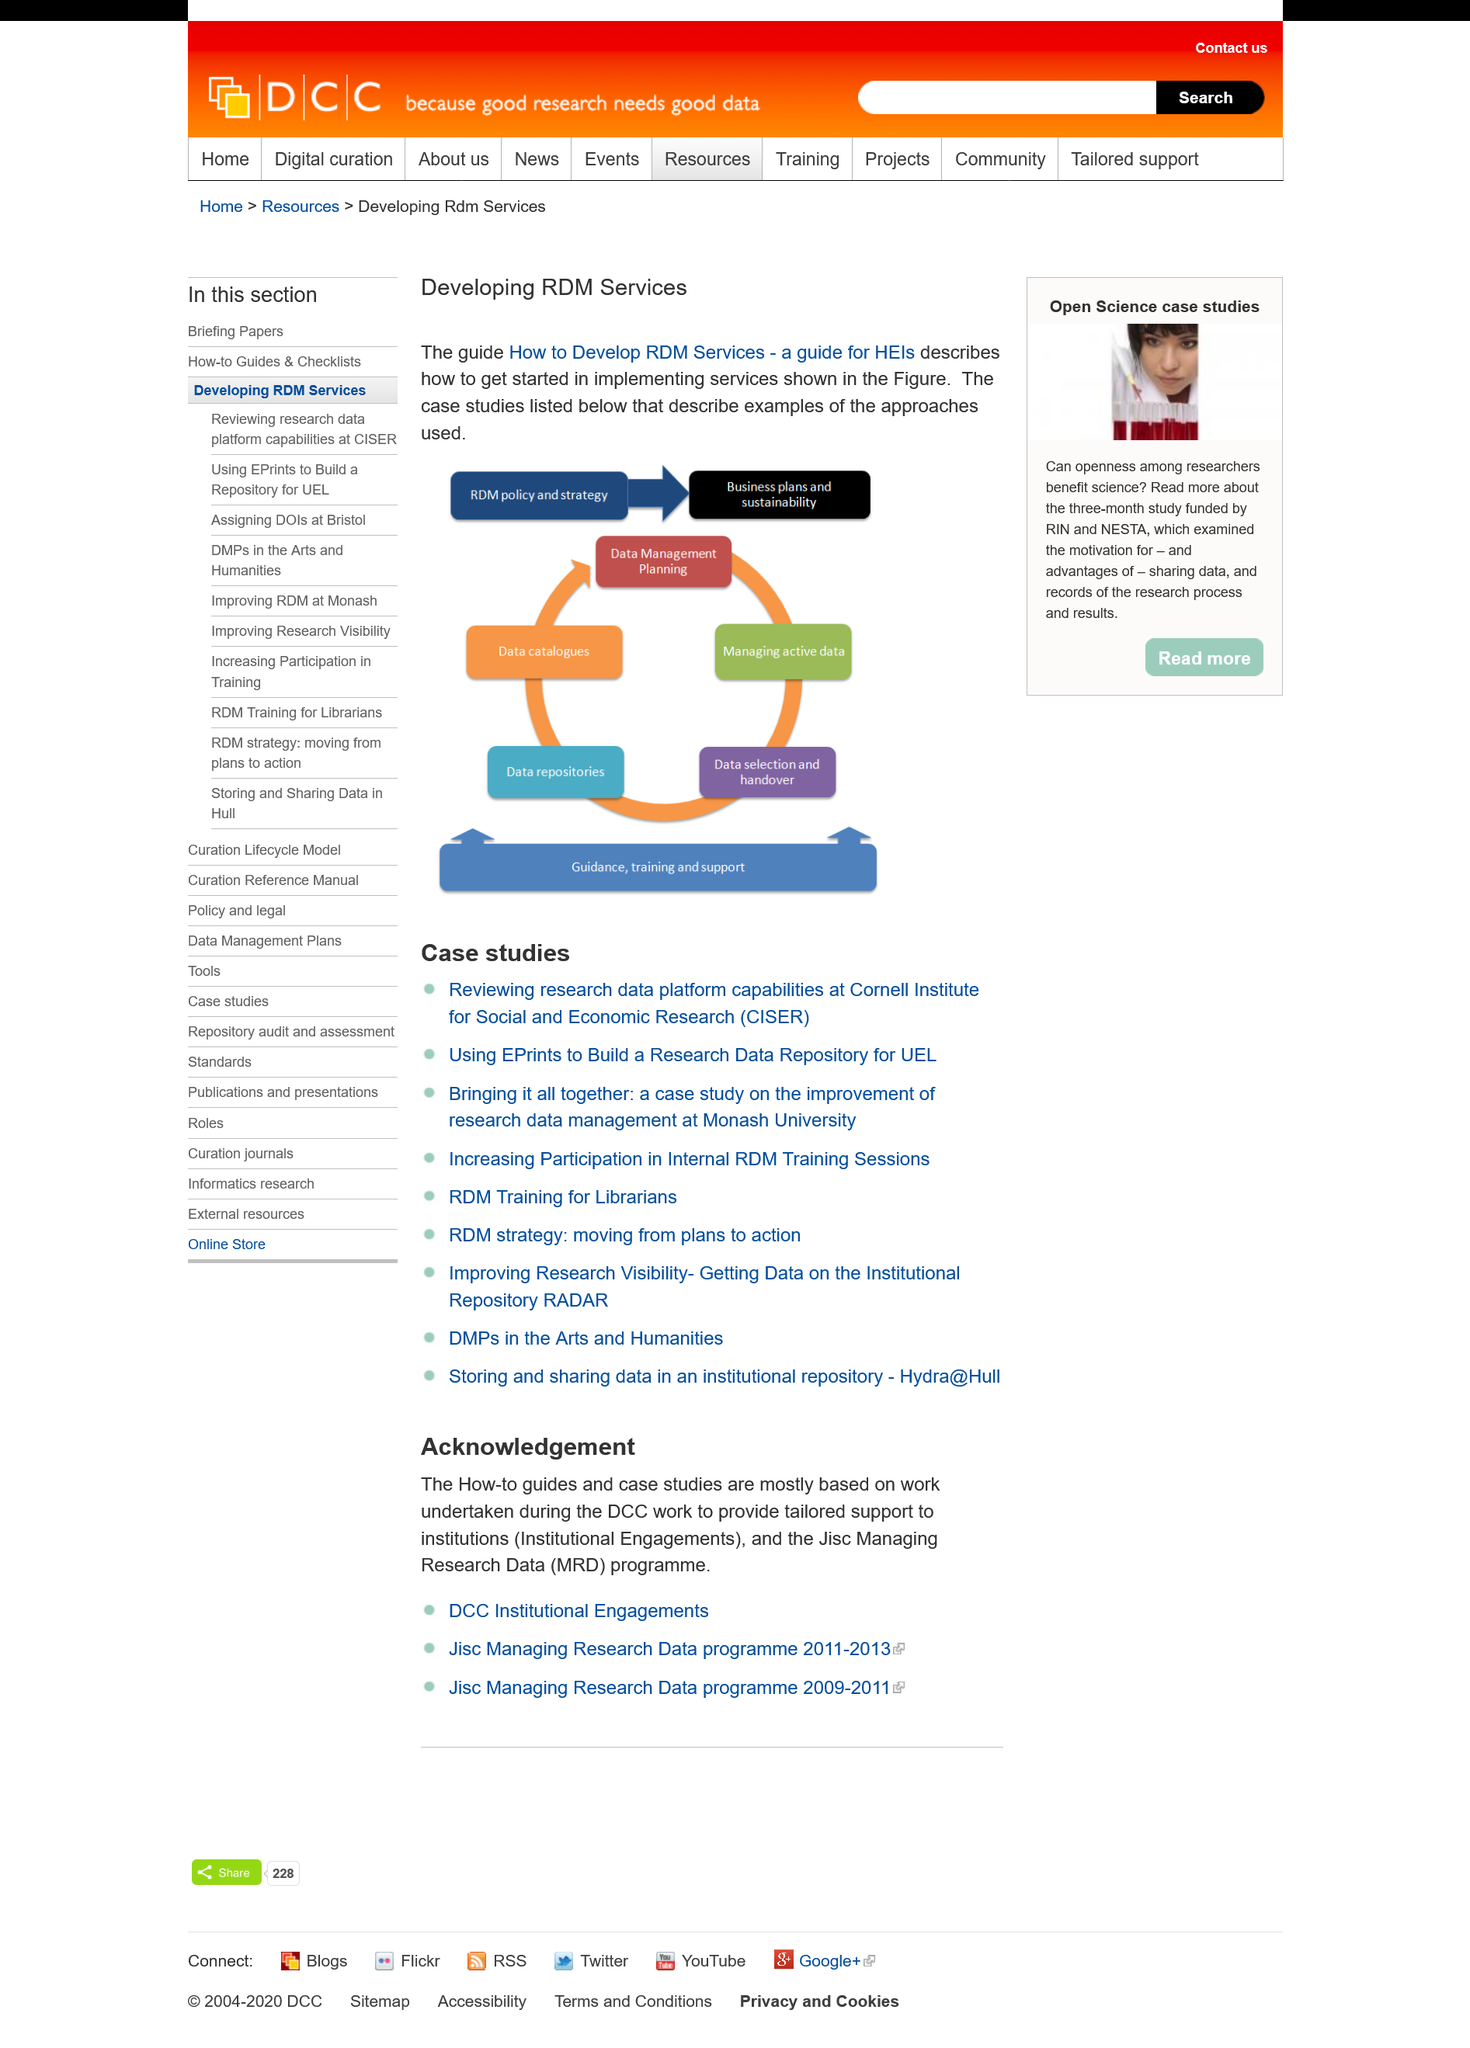Identify some key points in this picture. When developing RDM services, the guide "How to Develop RDM Services - a guide for HEis" should be used as a description on how to get started implementing the services shown in the figure. The diagram indicates that RDM policy and strategy will result in the development of business plans and sustainability goals for the organization. Data catalogues are depicted after data repositories on the diagram. 